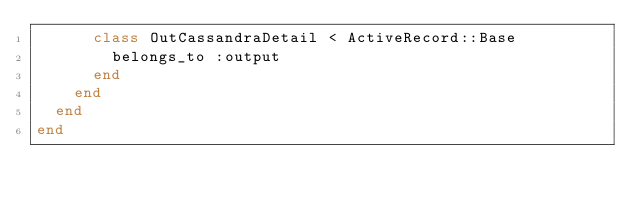<code> <loc_0><loc_0><loc_500><loc_500><_Ruby_>      class OutCassandraDetail < ActiveRecord::Base
        belongs_to :output
      end
    end
  end
end
</code> 